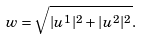Convert formula to latex. <formula><loc_0><loc_0><loc_500><loc_500>w = \sqrt { | u ^ { 1 } | ^ { 2 } + | u ^ { 2 } | ^ { 2 } } .</formula> 